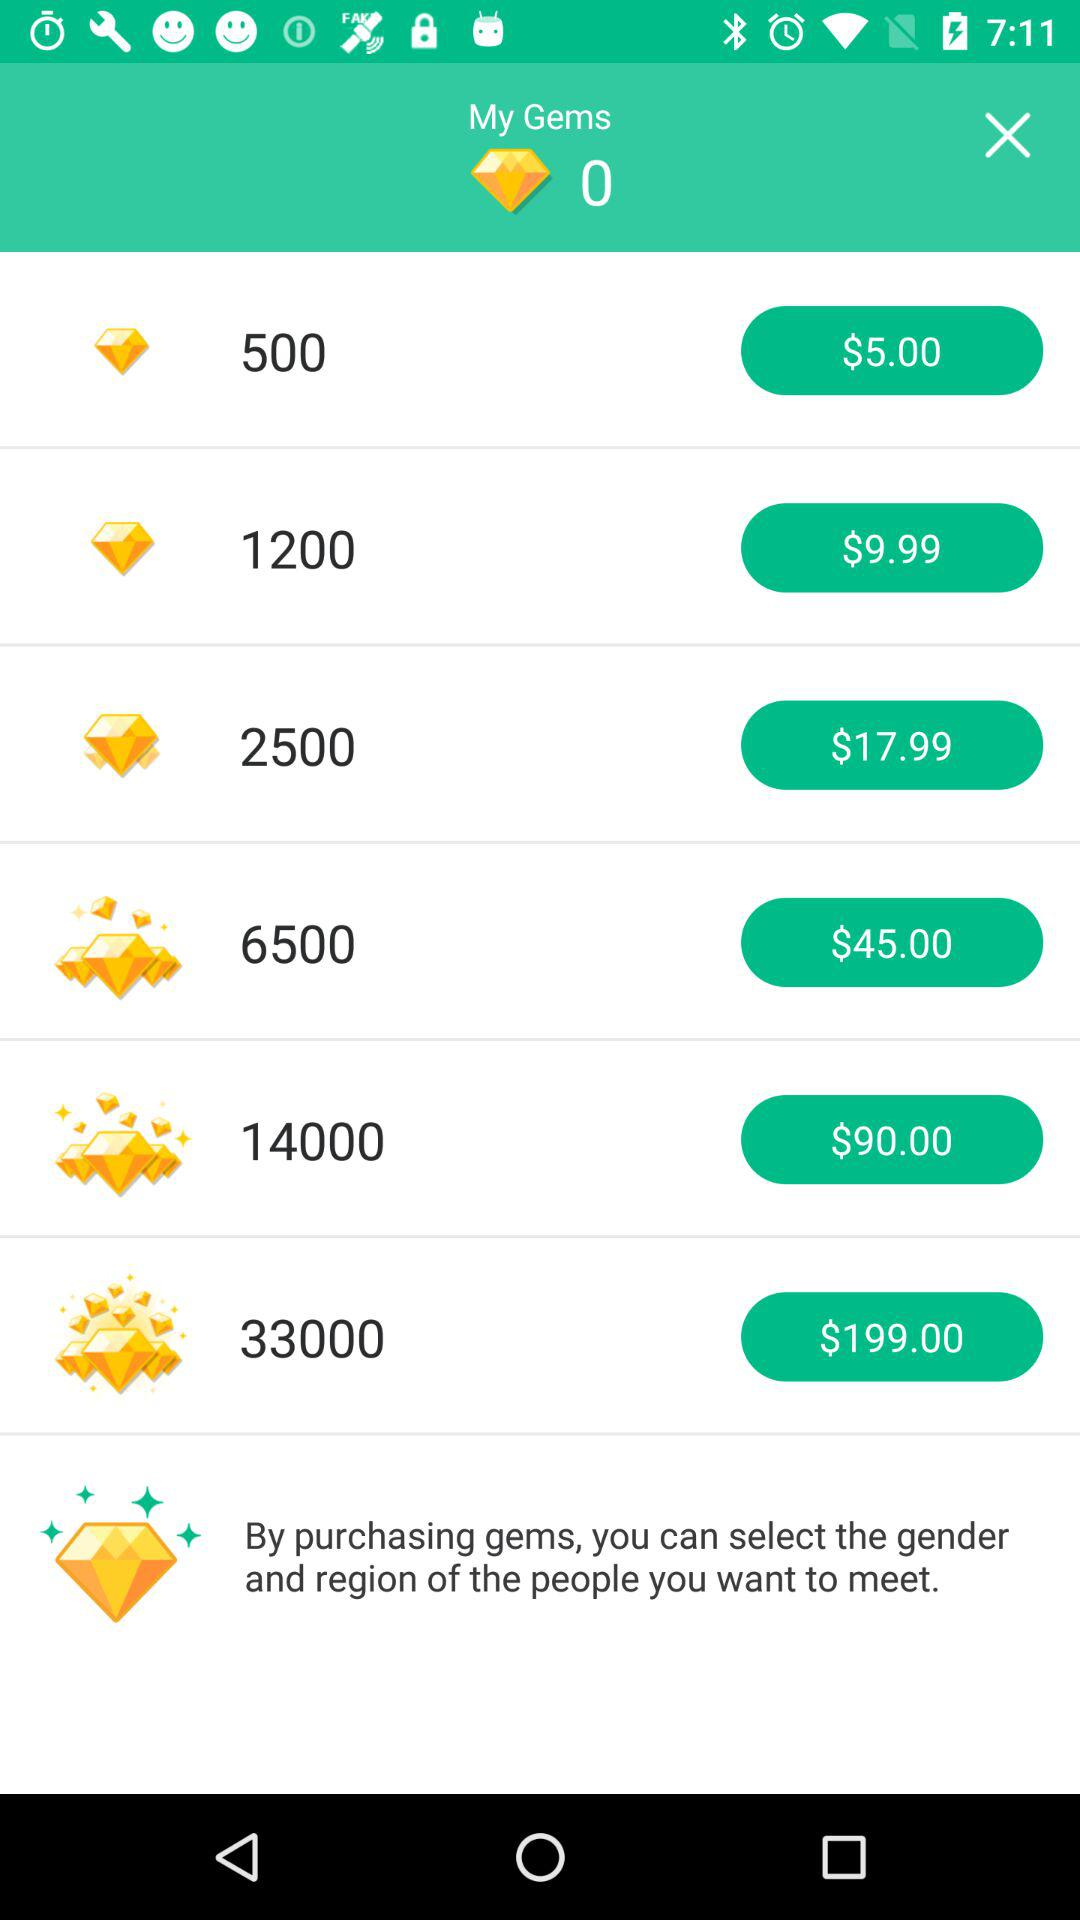What is the price for 6,500 gems? The price for 6,500 gems is $45. 